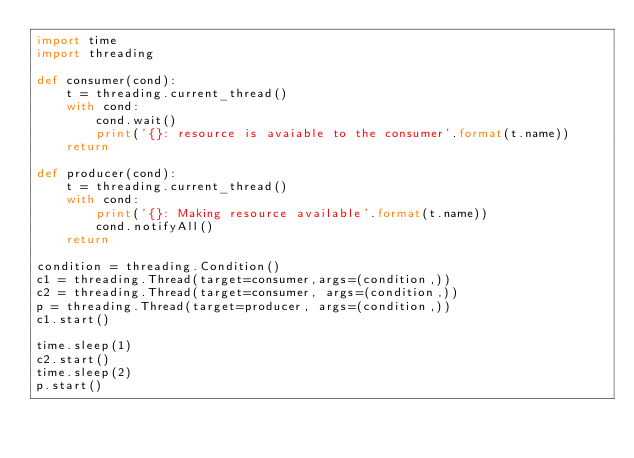<code> <loc_0><loc_0><loc_500><loc_500><_Python_>import time
import threading

def consumer(cond):
    t = threading.current_thread()
    with cond:
        cond.wait()
        print('{}: resource is avaiable to the consumer'.format(t.name))
    return

def producer(cond):
    t = threading.current_thread()
    with cond:
        print('{}: Making resource available'.format(t.name))
        cond.notifyAll()
    return

condition = threading.Condition()
c1 = threading.Thread(target=consumer,args=(condition,))
c2 = threading.Thread(target=consumer, args=(condition,))
p = threading.Thread(target=producer, args=(condition,))
c1.start()

time.sleep(1)
c2.start()
time.sleep(2)
p.start()</code> 